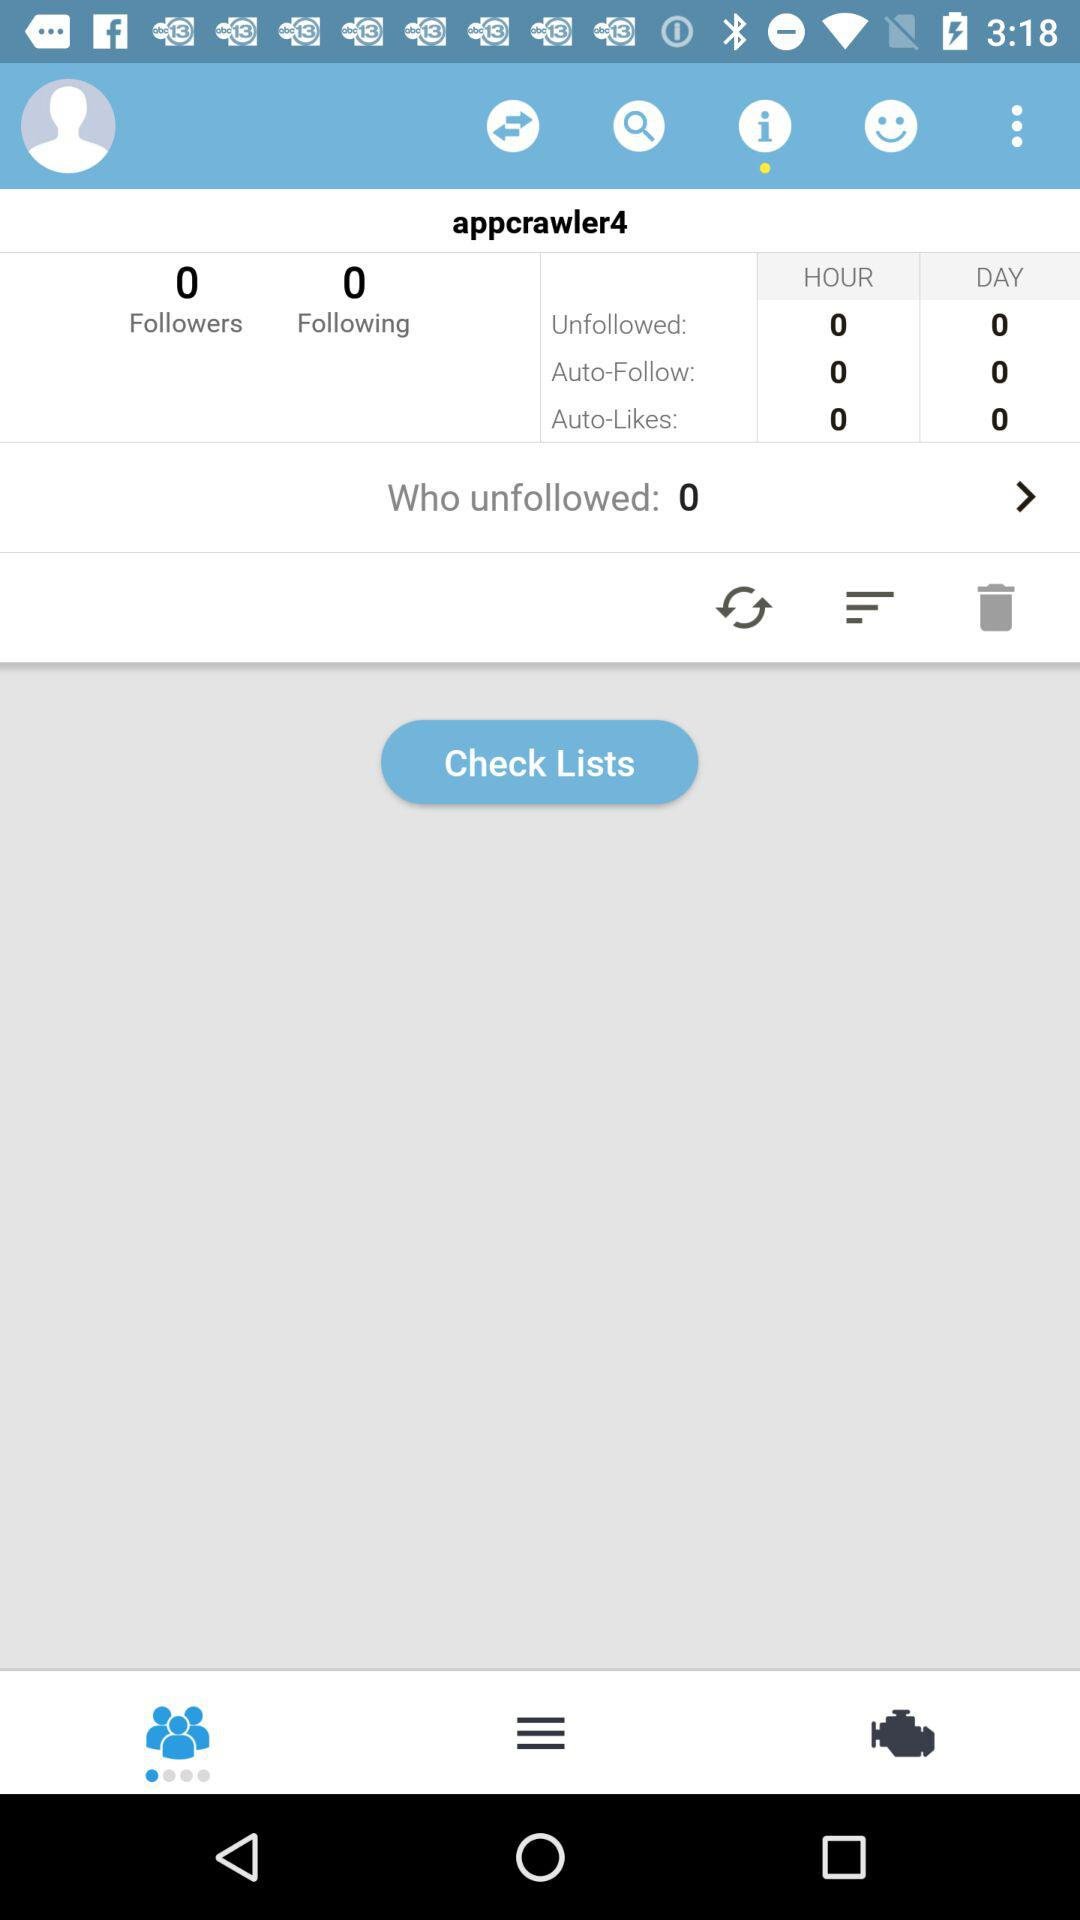What is the count of auto-follows in an hour? The count of auto-follows in an hour is 0. 